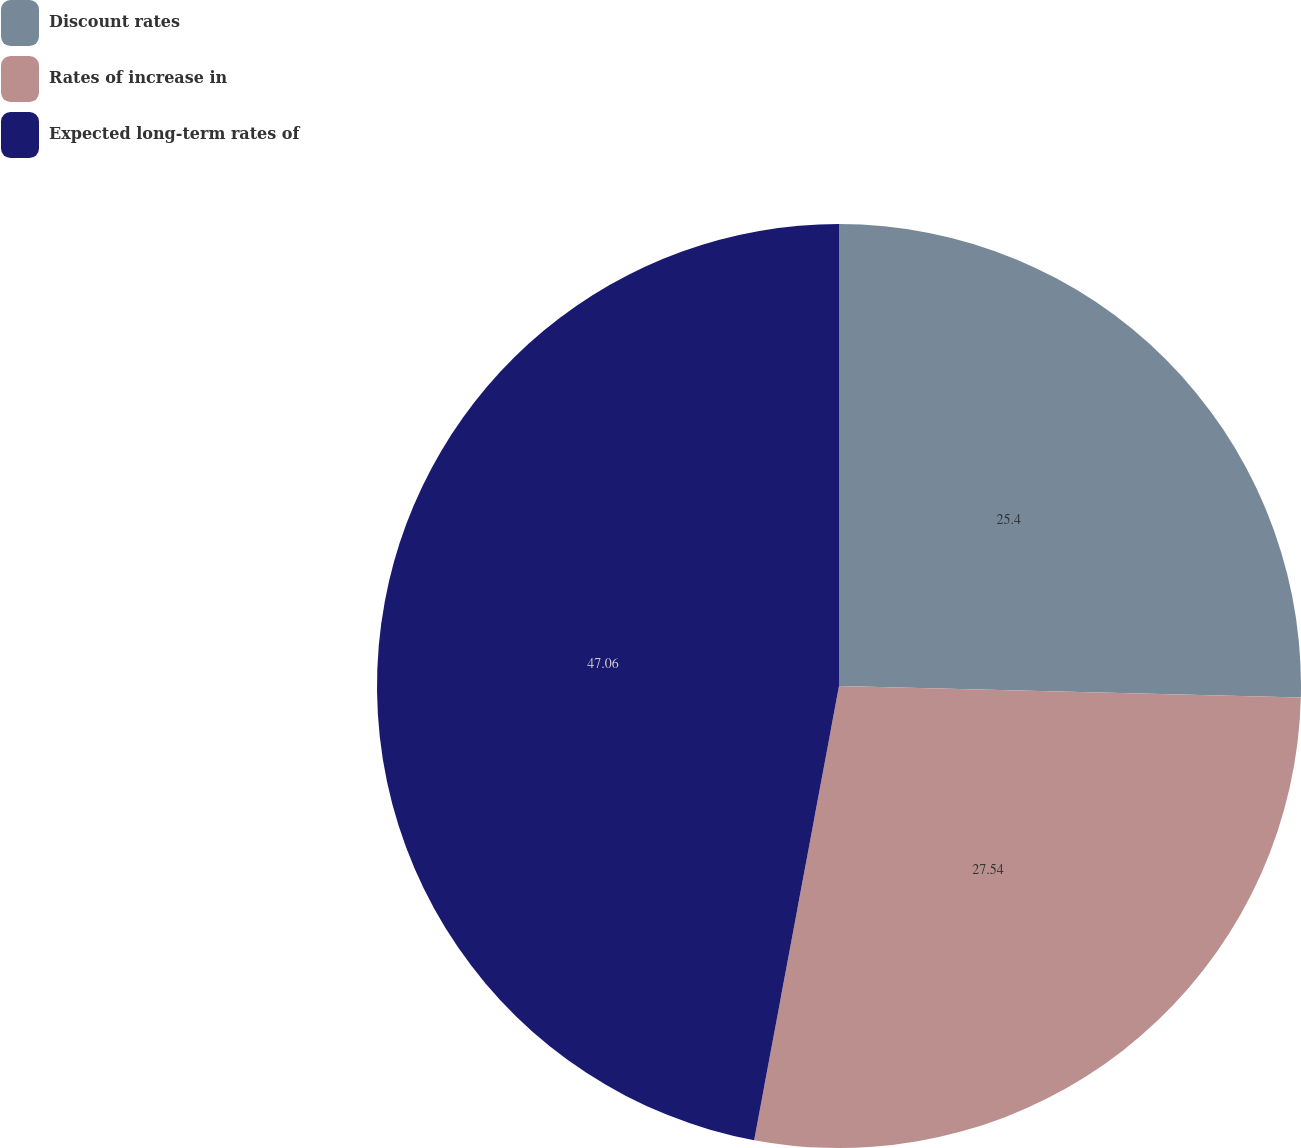Convert chart. <chart><loc_0><loc_0><loc_500><loc_500><pie_chart><fcel>Discount rates<fcel>Rates of increase in<fcel>Expected long-term rates of<nl><fcel>25.4%<fcel>27.54%<fcel>47.06%<nl></chart> 